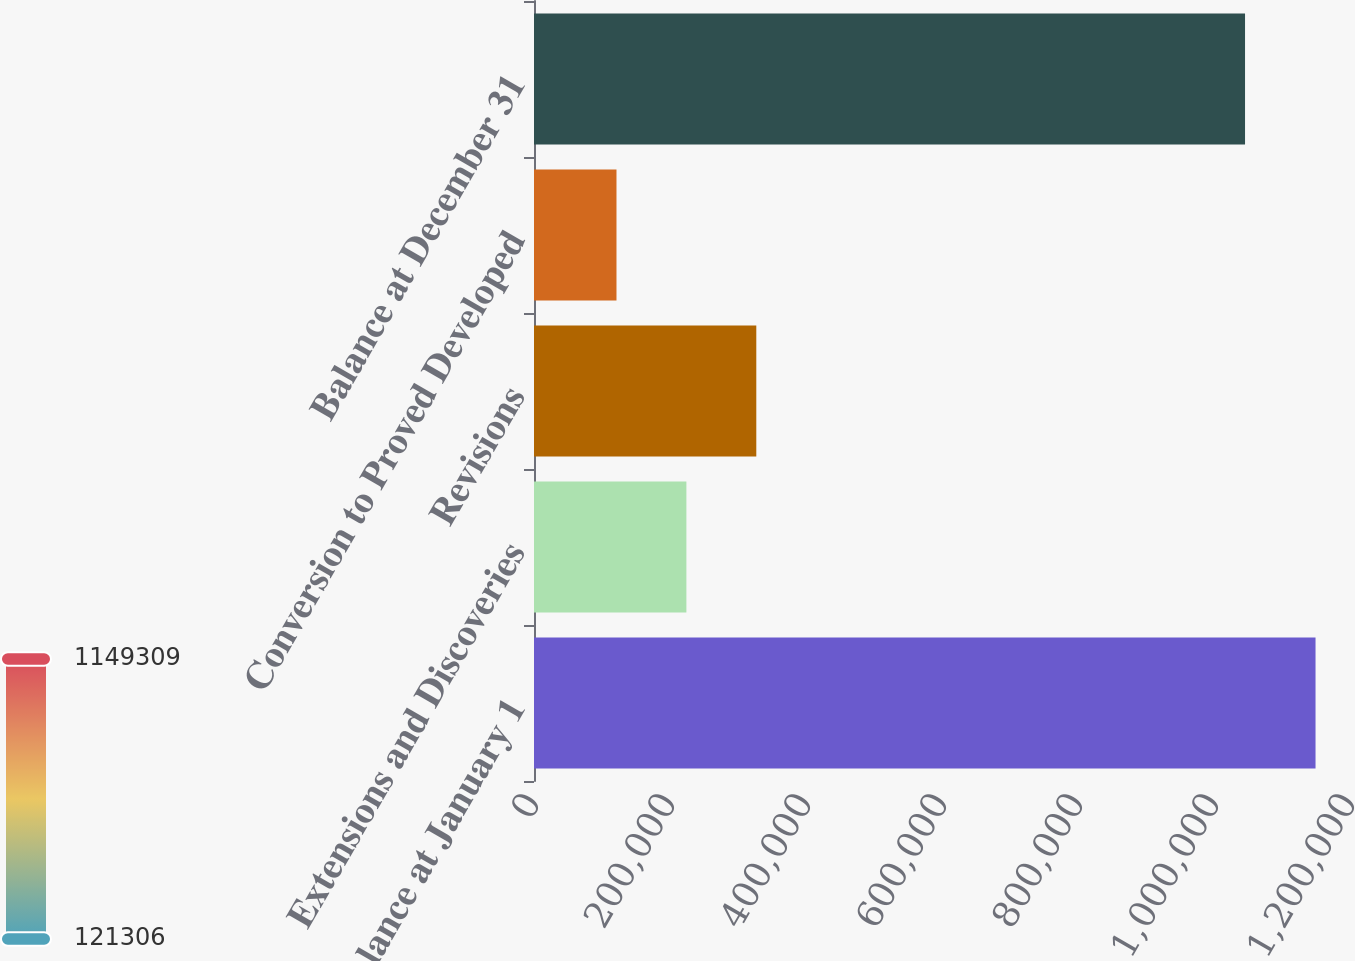Convert chart. <chart><loc_0><loc_0><loc_500><loc_500><bar_chart><fcel>Balance at January 1<fcel>Extensions and Discoveries<fcel>Revisions<fcel>Conversion to Proved Developed<fcel>Balance at December 31<nl><fcel>1.14931e+06<fcel>224106<fcel>326907<fcel>121306<fcel>1.04564e+06<nl></chart> 